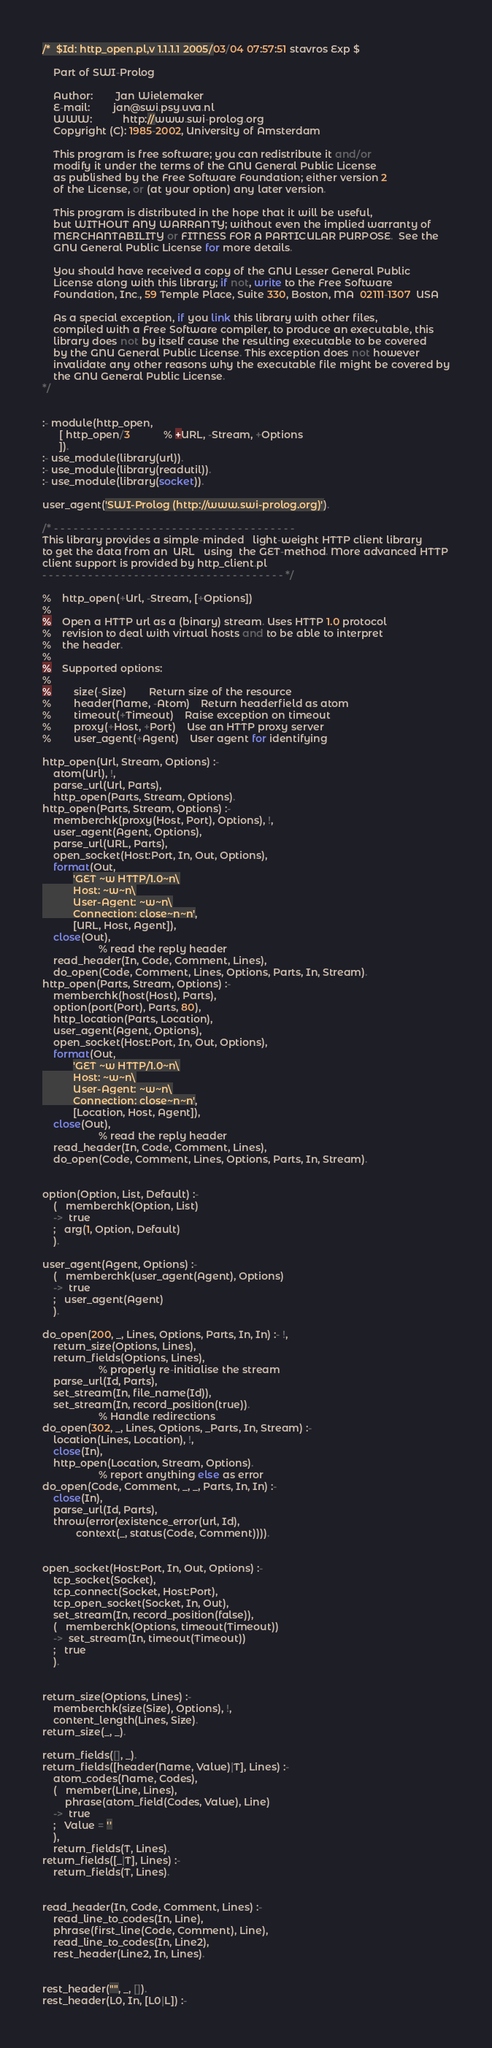<code> <loc_0><loc_0><loc_500><loc_500><_Perl_>/*  $Id: http_open.pl,v 1.1.1.1 2005/03/04 07:57:51 stavros Exp $

    Part of SWI-Prolog

    Author:        Jan Wielemaker
    E-mail:        jan@swi.psy.uva.nl
    WWW:           http://www.swi-prolog.org
    Copyright (C): 1985-2002, University of Amsterdam

    This program is free software; you can redistribute it and/or
    modify it under the terms of the GNU General Public License
    as published by the Free Software Foundation; either version 2
    of the License, or (at your option) any later version.

    This program is distributed in the hope that it will be useful,
    but WITHOUT ANY WARRANTY; without even the implied warranty of
    MERCHANTABILITY or FITNESS FOR A PARTICULAR PURPOSE.  See the
    GNU General Public License for more details.

    You should have received a copy of the GNU Lesser General Public
    License along with this library; if not, write to the Free Software
    Foundation, Inc., 59 Temple Place, Suite 330, Boston, MA  02111-1307  USA

    As a special exception, if you link this library with other files,
    compiled with a Free Software compiler, to produce an executable, this
    library does not by itself cause the resulting executable to be covered
    by the GNU General Public License. This exception does not however
    invalidate any other reasons why the executable file might be covered by
    the GNU General Public License.
*/


:- module(http_open,
	  [ http_open/3			% +URL, -Stream, +Options
	  ]).
:- use_module(library(url)).
:- use_module(library(readutil)).
:- use_module(library(socket)).

user_agent('SWI-Prolog (http://www.swi-prolog.org)').

/* - - - - - - - - - - - - - - - - - - - - - - - - - - - - - - - - - - - - -
This library provides a simple-minded   light-weight HTTP client library
to get the data from an  URL   using  the GET-method. More advanced HTTP
client support is provided by http_client.pl
- - - - - - - - - - - - - - - - - - - - - - - - - - - - - - - - - - - - - */

%	http_open(+Url, -Stream, [+Options])
%	
%	Open a HTTP url as a (binary) stream. Uses HTTP 1.0 protocol
%	revision to deal with virtual hosts and to be able to interpret
%	the header.
%	
%	Supported options:
%	
%		size(-Size)		Return size of the resource
%		header(Name, -Atom)	Return headerfield as atom
%		timeout(+Timeout)	Raise exception on timeout
%		proxy(+Host, +Port)	Use an HTTP proxy server
%		user_agent(+Agent)	User agent for identifying

http_open(Url, Stream, Options) :-
	atom(Url), !,
	parse_url(Url, Parts),
	http_open(Parts, Stream, Options).
http_open(Parts, Stream, Options) :-
	memberchk(proxy(Host, Port), Options), !,
	user_agent(Agent, Options),
	parse_url(URL, Parts),
	open_socket(Host:Port, In, Out, Options),
	format(Out,
	       'GET ~w HTTP/1.0~n\
	       Host: ~w~n\
	       User-Agent: ~w~n\
	       Connection: close~n~n',
	       [URL, Host, Agent]),
	close(Out),
					% read the reply header
	read_header(In, Code, Comment, Lines),
	do_open(Code, Comment, Lines, Options, Parts, In, Stream).
http_open(Parts, Stream, Options) :-
	memberchk(host(Host), Parts),
	option(port(Port), Parts, 80),
	http_location(Parts, Location),
	user_agent(Agent, Options),
	open_socket(Host:Port, In, Out, Options),
	format(Out,
	       'GET ~w HTTP/1.0~n\
	       Host: ~w~n\
	       User-Agent: ~w~n\
	       Connection: close~n~n',
	       [Location, Host, Agent]),
	close(Out),
					% read the reply header
	read_header(In, Code, Comment, Lines),
	do_open(Code, Comment, Lines, Options, Parts, In, Stream).


option(Option, List, Default) :-
	(   memberchk(Option, List)
	->  true
	;   arg(1, Option, Default)
	).

user_agent(Agent, Options) :-
	(   memberchk(user_agent(Agent), Options)
	->  true
	;   user_agent(Agent)
	).

do_open(200, _, Lines, Options, Parts, In, In) :- !,
	return_size(Options, Lines),
	return_fields(Options, Lines),
					% properly re-initialise the stream
	parse_url(Id, Parts),
	set_stream(In, file_name(Id)),
	set_stream(In, record_position(true)).
					% Handle redirections
do_open(302, _, Lines, Options, _Parts, In, Stream) :-
	location(Lines, Location), !,
	close(In),
	http_open(Location, Stream, Options).
					% report anything else as error
do_open(Code, Comment, _, _, Parts, In, In) :-
	close(In),
	parse_url(Id, Parts),
	throw(error(existence_error(url, Id),
		    context(_, status(Code, Comment)))).


open_socket(Host:Port, In, Out, Options) :-
	tcp_socket(Socket),
	tcp_connect(Socket, Host:Port),
	tcp_open_socket(Socket, In, Out),
	set_stream(In, record_position(false)),
	(   memberchk(Options, timeout(Timeout))
	->  set_stream(In, timeout(Timeout))
	;   true
	).


return_size(Options, Lines) :-
	memberchk(size(Size), Options), !,
	content_length(Lines, Size).
return_size(_, _).

return_fields([], _).
return_fields([header(Name, Value)|T], Lines) :-
	atom_codes(Name, Codes),
	(   member(Line, Lines),
	    phrase(atom_field(Codes, Value), Line)
	->  true
	;   Value = ''
	),
	return_fields(T, Lines).
return_fields([_|T], Lines) :-
	return_fields(T, Lines).


read_header(In, Code, Comment, Lines) :-
	read_line_to_codes(In, Line),
	phrase(first_line(Code, Comment), Line),
	read_line_to_codes(In, Line2),
	rest_header(Line2, In, Lines).


rest_header("", _, []).
rest_header(L0, In, [L0|L]) :-</code> 